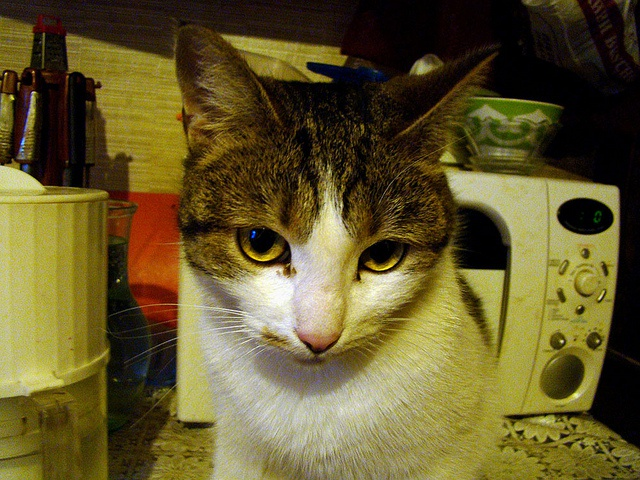Describe the objects in this image and their specific colors. I can see cat in black, olive, and maroon tones, microwave in black, tan, and olive tones, vase in black, maroon, and olive tones, and bowl in black, darkgreen, and gray tones in this image. 